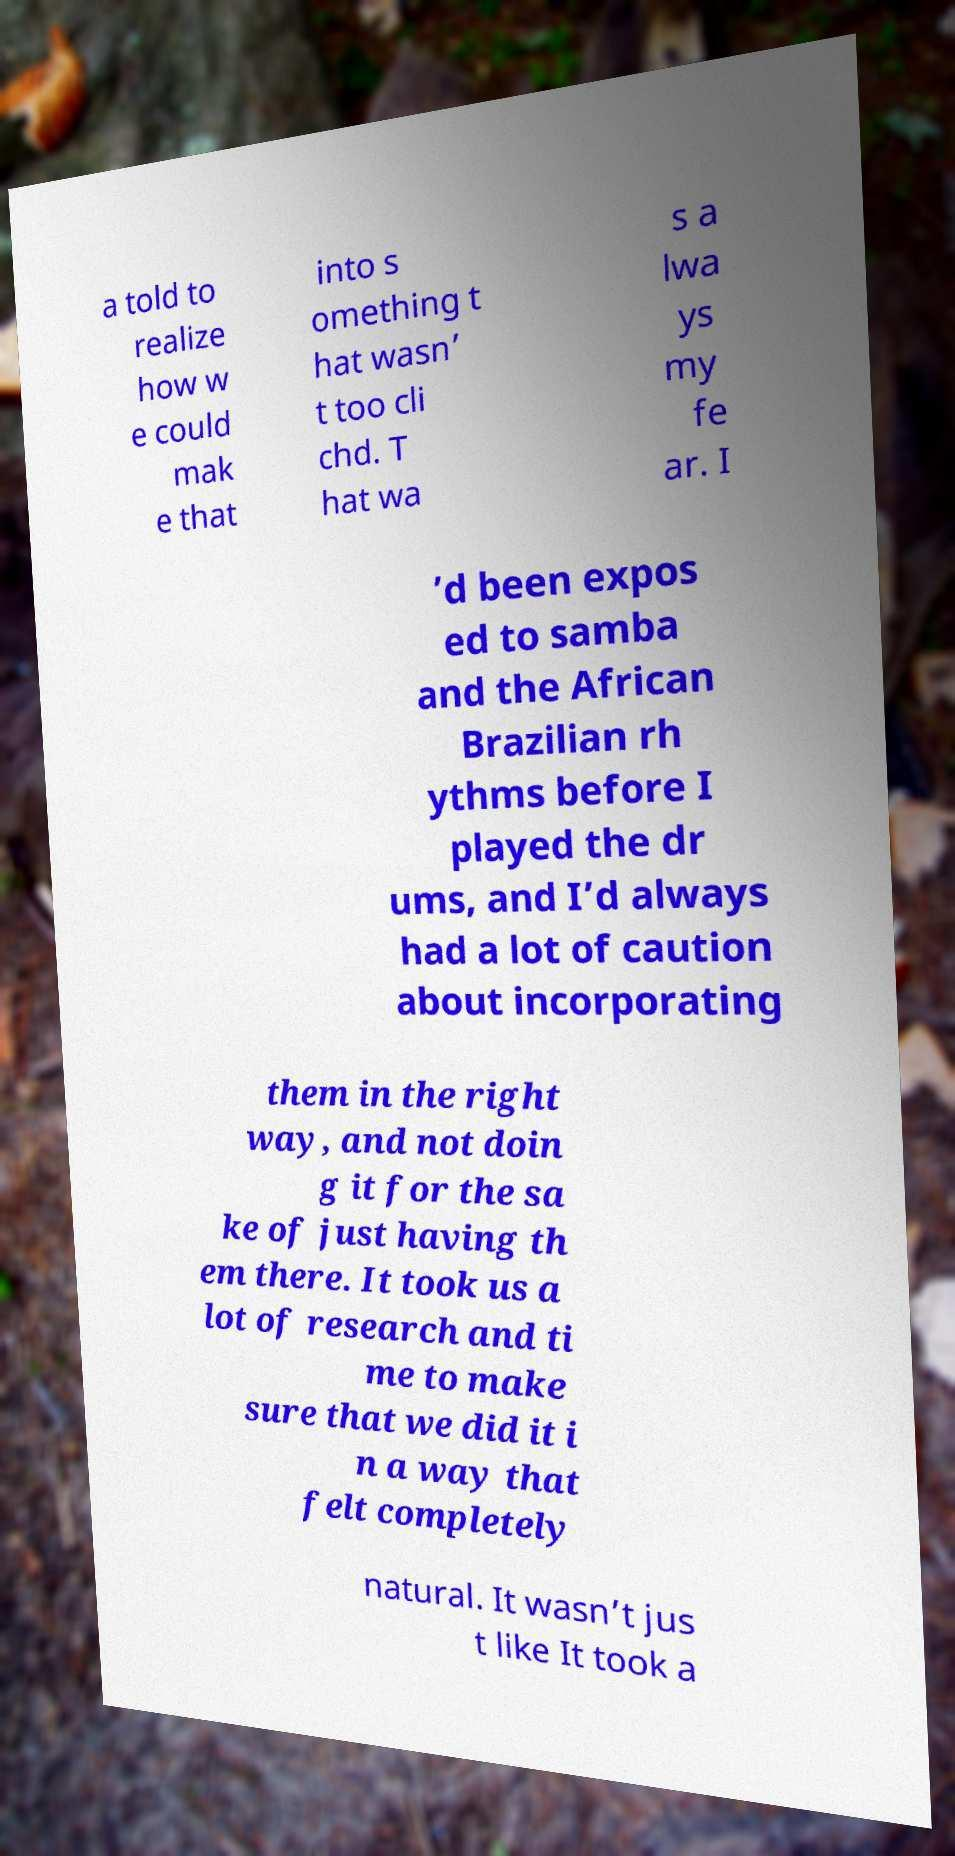I need the written content from this picture converted into text. Can you do that? a told to realize how w e could mak e that into s omething t hat wasn’ t too cli chd. T hat wa s a lwa ys my fe ar. I ’d been expos ed to samba and the African Brazilian rh ythms before I played the dr ums, and I’d always had a lot of caution about incorporating them in the right way, and not doin g it for the sa ke of just having th em there. It took us a lot of research and ti me to make sure that we did it i n a way that felt completely natural. It wasn’t jus t like It took a 